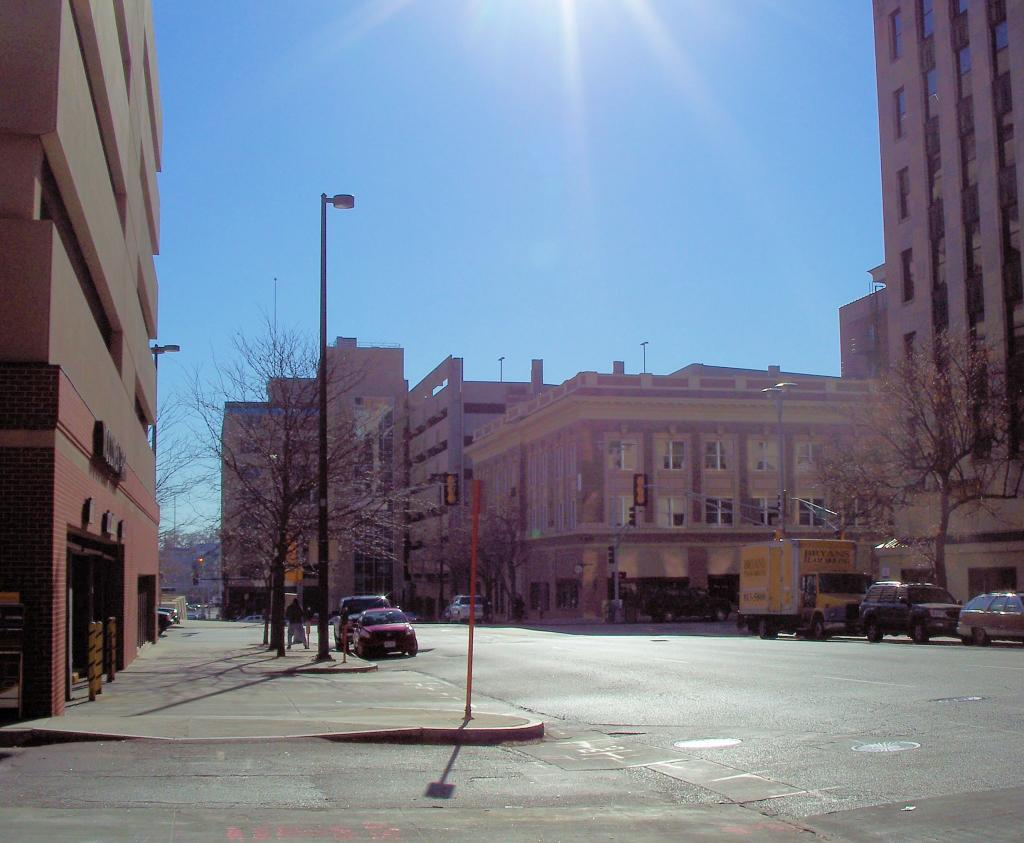What type of structures can be seen in the image? There are buildings with windows in the image. What natural elements are present in the image? There are trees visible in the image. What type of lighting is present in the image? There is a street light in the image. What type of transportation is visible in the image? There are vehicles on the road in the image. What part of the natural environment is visible in the image? The sky is visible in the image. What type of cakes are being taught in the prose section of the image? There is no reference to cakes, teaching, or prose in the image; it features buildings, trees, a street light, vehicles, and the sky. 